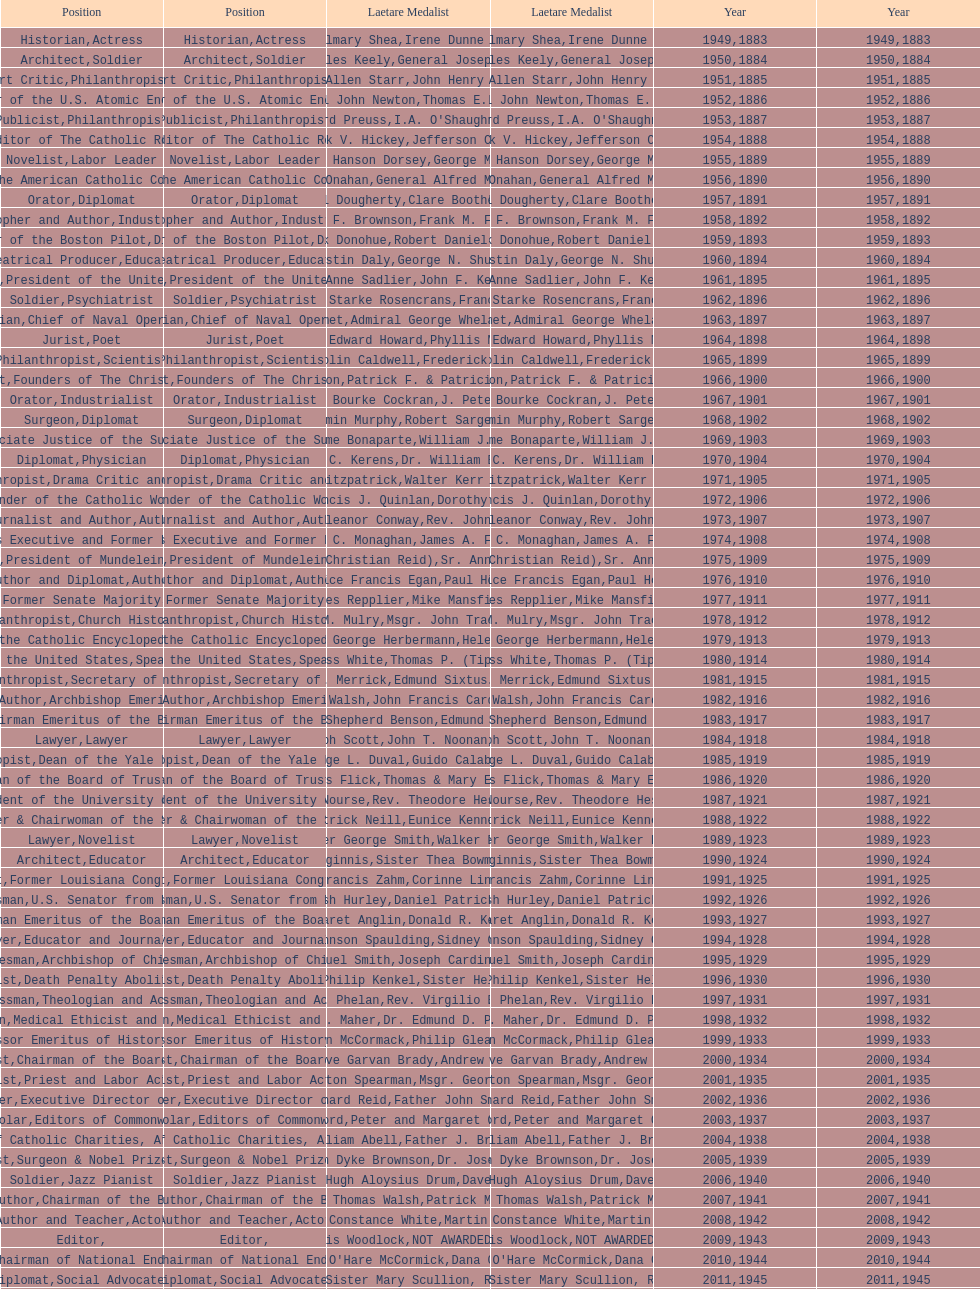Can you give me this table as a dict? {'header': ['Position', 'Position', 'Laetare Medalist', 'Laetare Medalist', 'Year', 'Year'], 'rows': [['Historian', 'Actress', 'John Gilmary Shea', 'Irene Dunne Griffin', '1949', '1883'], ['Architect', 'Soldier', 'Patrick Charles Keely', 'General Joseph L. Collins', '1950', '1884'], ['Art Critic', 'Philanthropist', 'Eliza Allen Starr', 'John Henry Phelan', '1951', '1885'], ['Engineer', 'Member of the U.S. Atomic Energy Commission', 'General John Newton', 'Thomas E. Murray', '1952', '1886'], ['Publicist', 'Philanthropist', 'Edward Preuss', "I.A. O'Shaughnessy", '1953', '1887'], ['Founder and Editor of The Catholic Review', 'Diplomat', 'Patrick V. Hickey', 'Jefferson Caffery', '1954', '1888'], ['Novelist', 'Labor Leader', 'Anna Hanson Dorsey', 'George Meany', '1955', '1889'], ['Organizer of the American Catholic Congress', 'Soldier', 'William J. Onahan', 'General Alfred M. Gruenther', '1956', '1890'], ['Orator', 'Diplomat', 'Daniel Dougherty', 'Clare Boothe Luce', '1957', '1891'], ['Philosopher and Author', 'Industrialist', 'Henry F. Brownson', 'Frank M. Folsom', '1958', '1892'], ['Founder of the Boston Pilot', 'Diplomat', 'Patrick Donohue', 'Robert Daniel Murphy', '1959', '1893'], ['Theatrical Producer', 'Educator', 'Augustin Daly', 'George N. Shuster', '1960', '1894'], ['Novelist', 'President of the United States', 'Mary Anne Sadlier', 'John F. Kennedy', '1961', '1895'], ['Soldier', 'Psychiatrist', 'General William Starke Rosencrans', 'Francis J. Braceland', '1962', '1896'], ['Physician', 'Chief of Naval Operations', 'Thomas Addis Emmet', 'Admiral George Whelan Anderson, Jr.', '1963', '1897'], ['Jurist', 'Poet', 'Timothy Edward Howard', 'Phyllis McGinley', '1964', '1898'], ['Philanthropist', 'Scientist', 'Mary Gwendolin Caldwell', 'Frederick D. Rossini', '1965', '1899'], ['Philanthropist', 'Founders of The Christian Movement', 'John A. Creighton', 'Patrick F. & Patricia Caron Crowley', '1966', '1900'], ['Orator', 'Industrialist', 'William Bourke Cockran', 'J. Peter Grace', '1967', '1901'], ['Surgeon', 'Diplomat', 'John Benjamin Murphy', 'Robert Sargent Shriver', '1968', '1902'], ['Lawyer', 'Associate Justice of the Supreme Court', 'Charles Jerome Bonaparte', 'William J. Brennan Jr.', '1969', '1903'], ['Diplomat', 'Physician', 'Richard C. Kerens', 'Dr. William B. Walsh', '1970', '1904'], ['Philanthropist', 'Drama Critic and Author', 'Thomas B. Fitzpatrick', 'Walter Kerr & Jean Kerr', '1971', '1905'], ['Physician', 'Founder of the Catholic Worker Movement', 'Francis J. Quinlan', 'Dorothy Day', '1972', '1906'], ['Journalist and Author', 'Author', 'Katherine Eleanor Conway', "Rev. John A. O'Brien", '1973', '1907'], ['Economist', 'Business Executive and Former Postmaster General', 'James C. Monaghan', 'James A. Farley', '1974', '1908'], ['Novelist', 'President of Mundelein College', 'Frances Tieran (Christian Reid)', 'Sr. Ann Ida Gannon, BMV', '1975', '1909'], ['Author and Diplomat', 'Author', 'Maurice Francis Egan', 'Paul Horgan', '1976', '1910'], ['Author', 'Former Senate Majority Leader', 'Agnes Repplier', 'Mike Mansfield', '1977', '1911'], ['Philanthropist', 'Church Historian', 'Thomas M. Mulry', 'Msgr. John Tracy Ellis', '1978', '1912'], ['Editor of the Catholic Encyclopedia', 'Actress', 'Charles George Herbermann', 'Helen Hayes', '1979', '1913'], ['Chief Justice of the United States', 'Speaker of the House', 'Edward Douglass White', "Thomas P. (Tip) O'Neill Jr.", '1980', '1914'], ['Philanthropist', 'Secretary of State', 'Mary V. Merrick', 'Edmund Sixtus Muskie', '1981', '1915'], ['Physician and Author', 'Archbishop Emeritus of Detroit', 'James Joseph Walsh', 'John Francis Cardinal Dearden', '1982', '1916'], ['Chief of Naval Operations', 'Chairman Emeritus of the Board of Trustees and his wife', 'Admiral William Shepherd Benson', 'Edmund & Evelyn Stephan', '1983', '1917'], ['Lawyer', 'Lawyer', 'Joseph Scott', 'John T. Noonan, Jr.', '1984', '1918'], ['Philanthropist', 'Dean of the Yale Law School', 'George L. Duval', 'Guido Calabresi', '1985', '1919'], ['Physician', 'Chairman of the Board of Trustees and his wife', 'Lawrence Francis Flick', 'Thomas & Mary Elizabeth Carney', '1986', '1920'], ['Artist', 'President of the University of Notre Dame', 'Elizabeth Nourse', 'Rev. Theodore Hesburgh, CSC', '1987', '1921'], ['Economist', 'Founder & Chairwoman of the Special Olympics', 'Charles Patrick Neill', 'Eunice Kennedy Shriver', '1988', '1922'], ['Lawyer', 'Novelist', 'Walter George Smith', 'Walker Percy', '1989', '1923'], ['Architect', 'Educator', 'Charles Donagh Maginnis', 'Sister Thea Bowman (posthumously)', '1990', '1924'], ['Scientist', 'Former Louisiana Congresswoman', 'Albert Francis Zahm', 'Corinne Lindy Boggs', '1991', '1925'], ['Businessman', 'U.S. Senator from New York', 'Edward Nash Hurley', 'Daniel Patrick Moynihan', '1992', '1926'], ['Actress', 'Chairman Emeritus of the Board of Trustees', 'Margaret Anglin', 'Donald R. Keough', '1993', '1927'], ['Lawyer', 'Educator and Journalist', 'John Johnson Spaulding', 'Sidney Callahan', '1994', '1928'], ['Statesman', 'Archbishop of Chicago', 'Alfred Emmanuel Smith', 'Joseph Cardinal Bernardin', '1995', '1929'], ['Publicist', 'Death Penalty Abolitionist', 'Frederick Philip Kenkel', 'Sister Helen Prejean', '1996', '1930'], ['Businessman', 'Theologian and Activist', 'James J. Phelan', 'Rev. Virgilio Elizondo', '1997', '1931'], ['Physician', 'Medical Ethicist and Educator', 'Stephen J. Maher', 'Dr. Edmund D. Pellegrino', '1998', '1932'], ['Artist', 'Professor Emeritus of History, Notre Dame', 'John McCormack', 'Philip Gleason', '1999', '1933'], ['Philanthropist', 'Chairman of the Board of Trustees', 'Genevieve Garvan Brady', 'Andrew McKenna', '2000', '1934'], ['Novelist', 'Priest and Labor Activist', 'Francis Hamilton Spearman', 'Msgr. George G. Higgins', '2001', '1935'], ['Journalist and Lawyer', 'Executive Director of Maryville Academy', 'Richard Reid', 'Father John Smyth', '2002', '1936'], ['Scholar', 'Editors of Commonweal', 'Jeremiah D. M. Ford', "Peter and Margaret O'Brien Steinfels", '2003', '1937'], ['Surgeon', 'President of Catholic Charities, Archdiocese of Boston', 'Irvin William Abell', 'Father J. Bryan Hehir', '2004', '1938'], ['Catechist', 'Surgeon & Nobel Prize Winner', 'Josephine Van Dyke Brownson', 'Dr. Joseph E. Murray', '2005', '1939'], ['Soldier', 'Jazz Pianist', 'General Hugh Aloysius Drum', 'Dave Brubeck', '2006', '1940'], ['Journalist and Author', 'Chairman of the Board of Trustees', 'William Thomas Walsh', 'Patrick McCartan', '2007', '1941'], ['Author and Teacher', 'Actor', 'Helen Constance White', 'Martin Sheen', '2008', '1942'], ['Editor', '', 'Thomas Francis Woodlock', 'NOT AWARDED (SEE BELOW)', '2009', '1943'], ['Journalist', 'Former Chairman of National Endowment for the Arts', "Anne O'Hare McCormick", 'Dana Gioia', '2010', '1944'], ['Diplomat', 'Social Advocates', 'Gardiner Howland Shaw', 'Sister Mary Scullion, R.S.M., & Joan McConnon', '2011', '1945'], ['Historian and Diplomat', 'Former President of Catholic Relief Services', 'Carlton J. H. Hayes', 'Ken Hackett', '2012', '1946'], ['Publisher and Civic Leader', 'Founders of S.P.R.E.D. (Special Religious Education Development Network)', 'William G. Bruce', 'Sister Susanne Gallagher, S.P.\\nSister Mary Therese Harrington, S.H.\\nRev. James H. McCarthy', '2013', '1947'], ['Postmaster General and Civic Leader', 'Professor of Biology at Brown University', 'Frank C. Walker', 'Kenneth R. Miller', '2014', '1948']]} Who has won this medal and the nobel prize as well? Dr. Joseph E. Murray. 